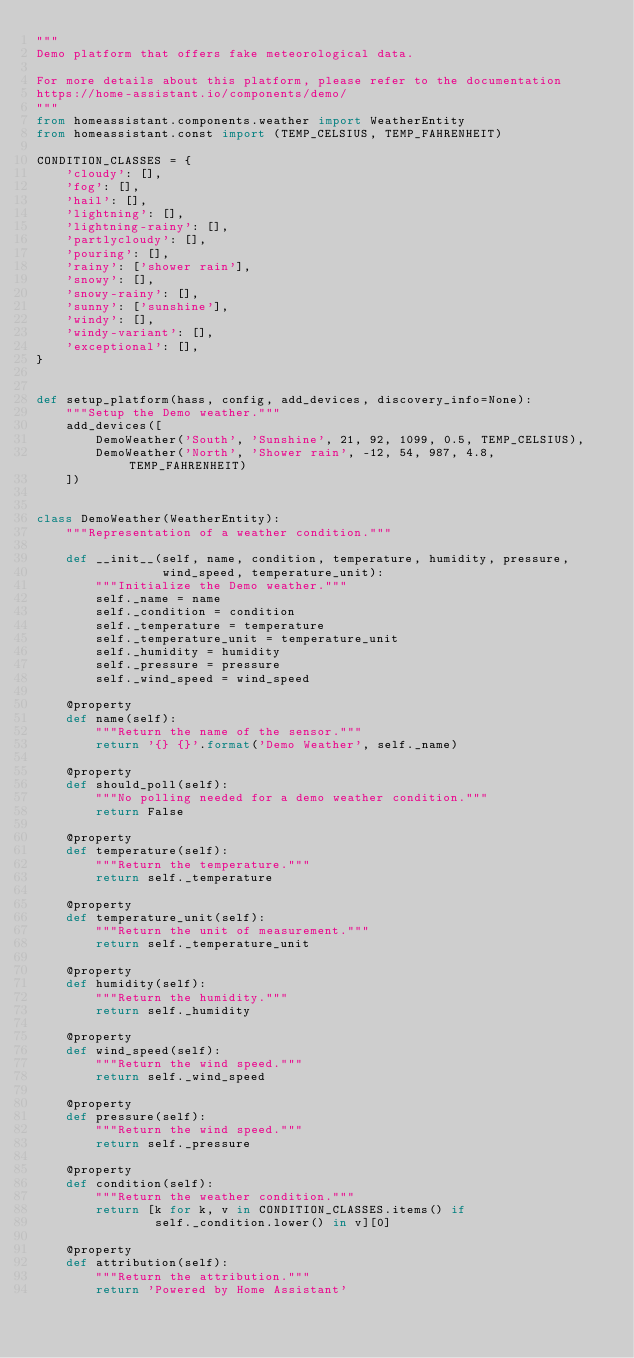Convert code to text. <code><loc_0><loc_0><loc_500><loc_500><_Python_>"""
Demo platform that offers fake meteorological data.

For more details about this platform, please refer to the documentation
https://home-assistant.io/components/demo/
"""
from homeassistant.components.weather import WeatherEntity
from homeassistant.const import (TEMP_CELSIUS, TEMP_FAHRENHEIT)

CONDITION_CLASSES = {
    'cloudy': [],
    'fog': [],
    'hail': [],
    'lightning': [],
    'lightning-rainy': [],
    'partlycloudy': [],
    'pouring': [],
    'rainy': ['shower rain'],
    'snowy': [],
    'snowy-rainy': [],
    'sunny': ['sunshine'],
    'windy': [],
    'windy-variant': [],
    'exceptional': [],
}


def setup_platform(hass, config, add_devices, discovery_info=None):
    """Setup the Demo weather."""
    add_devices([
        DemoWeather('South', 'Sunshine', 21, 92, 1099, 0.5, TEMP_CELSIUS),
        DemoWeather('North', 'Shower rain', -12, 54, 987, 4.8, TEMP_FAHRENHEIT)
    ])


class DemoWeather(WeatherEntity):
    """Representation of a weather condition."""

    def __init__(self, name, condition, temperature, humidity, pressure,
                 wind_speed, temperature_unit):
        """Initialize the Demo weather."""
        self._name = name
        self._condition = condition
        self._temperature = temperature
        self._temperature_unit = temperature_unit
        self._humidity = humidity
        self._pressure = pressure
        self._wind_speed = wind_speed

    @property
    def name(self):
        """Return the name of the sensor."""
        return '{} {}'.format('Demo Weather', self._name)

    @property
    def should_poll(self):
        """No polling needed for a demo weather condition."""
        return False

    @property
    def temperature(self):
        """Return the temperature."""
        return self._temperature

    @property
    def temperature_unit(self):
        """Return the unit of measurement."""
        return self._temperature_unit

    @property
    def humidity(self):
        """Return the humidity."""
        return self._humidity

    @property
    def wind_speed(self):
        """Return the wind speed."""
        return self._wind_speed

    @property
    def pressure(self):
        """Return the wind speed."""
        return self._pressure

    @property
    def condition(self):
        """Return the weather condition."""
        return [k for k, v in CONDITION_CLASSES.items() if
                self._condition.lower() in v][0]

    @property
    def attribution(self):
        """Return the attribution."""
        return 'Powered by Home Assistant'
</code> 